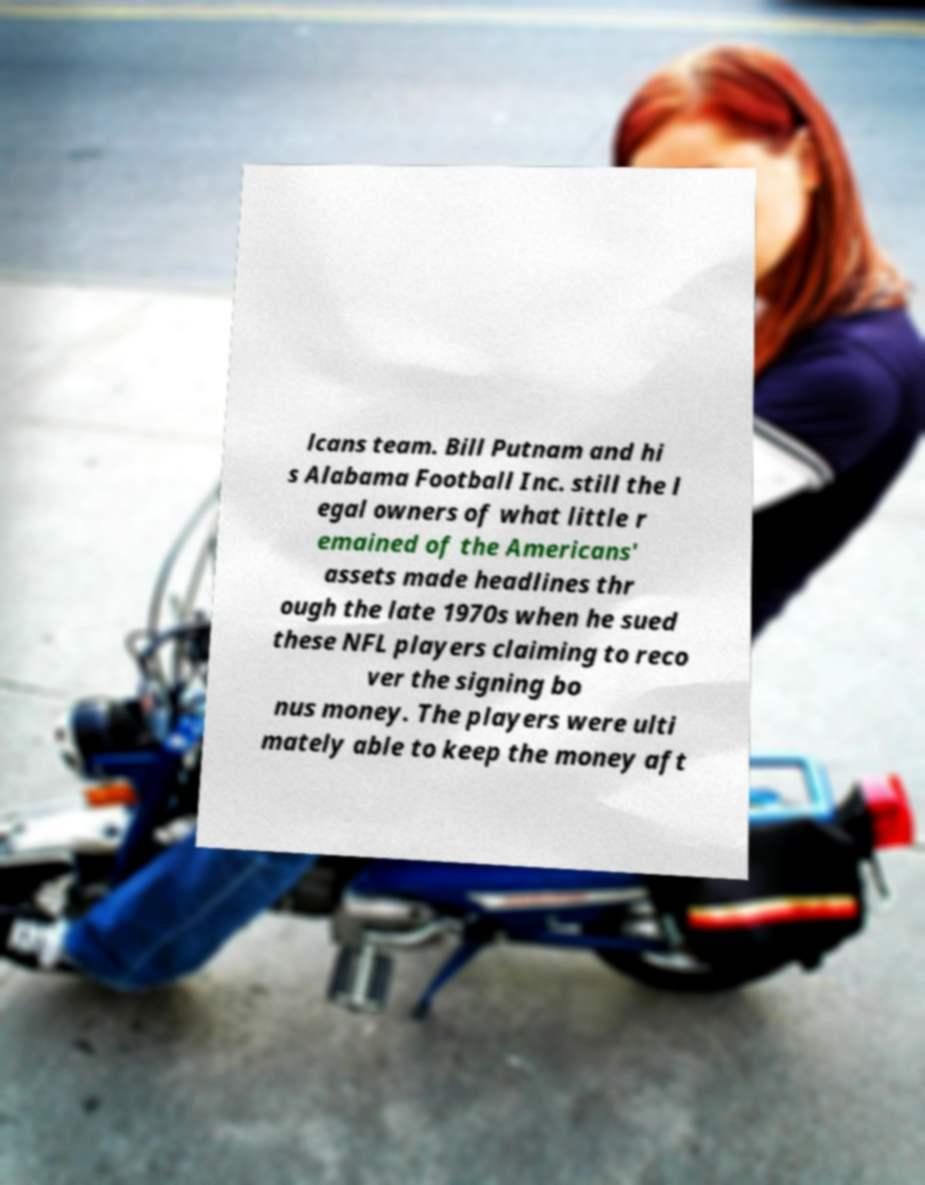For documentation purposes, I need the text within this image transcribed. Could you provide that? lcans team. Bill Putnam and hi s Alabama Football Inc. still the l egal owners of what little r emained of the Americans' assets made headlines thr ough the late 1970s when he sued these NFL players claiming to reco ver the signing bo nus money. The players were ulti mately able to keep the money aft 